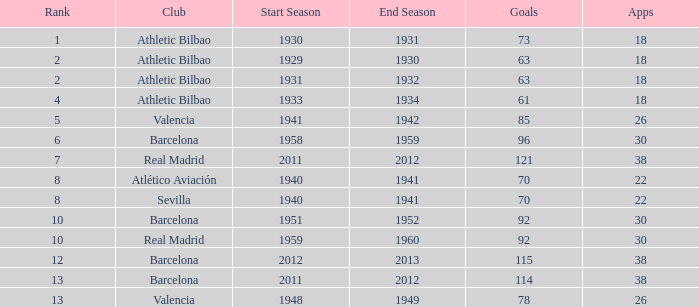Who was the club having less than 22 apps and ranked less than 2? Athletic Bilbao. 